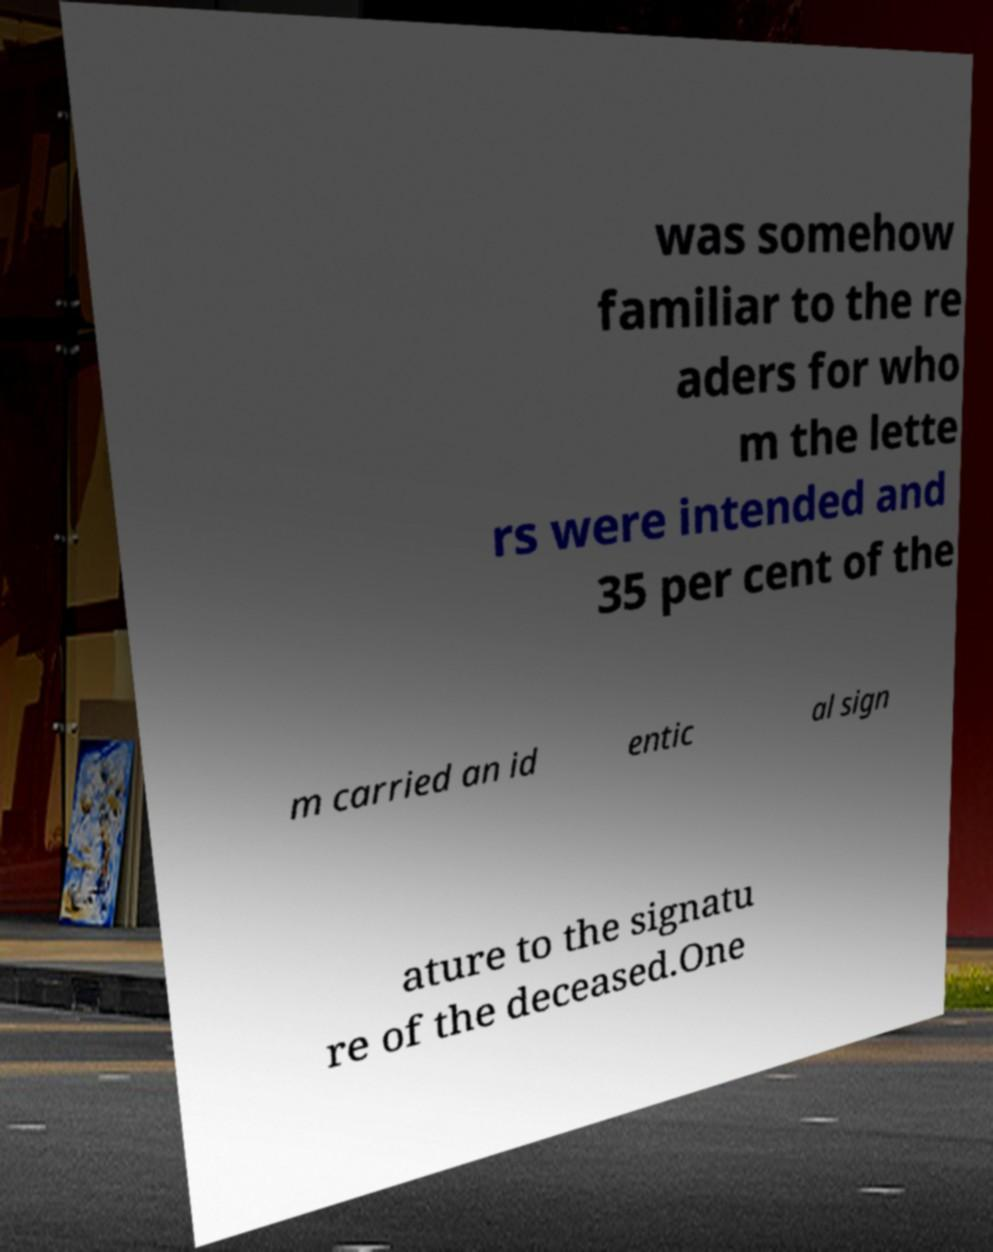Please read and relay the text visible in this image. What does it say? was somehow familiar to the re aders for who m the lette rs were intended and 35 per cent of the m carried an id entic al sign ature to the signatu re of the deceased.One 